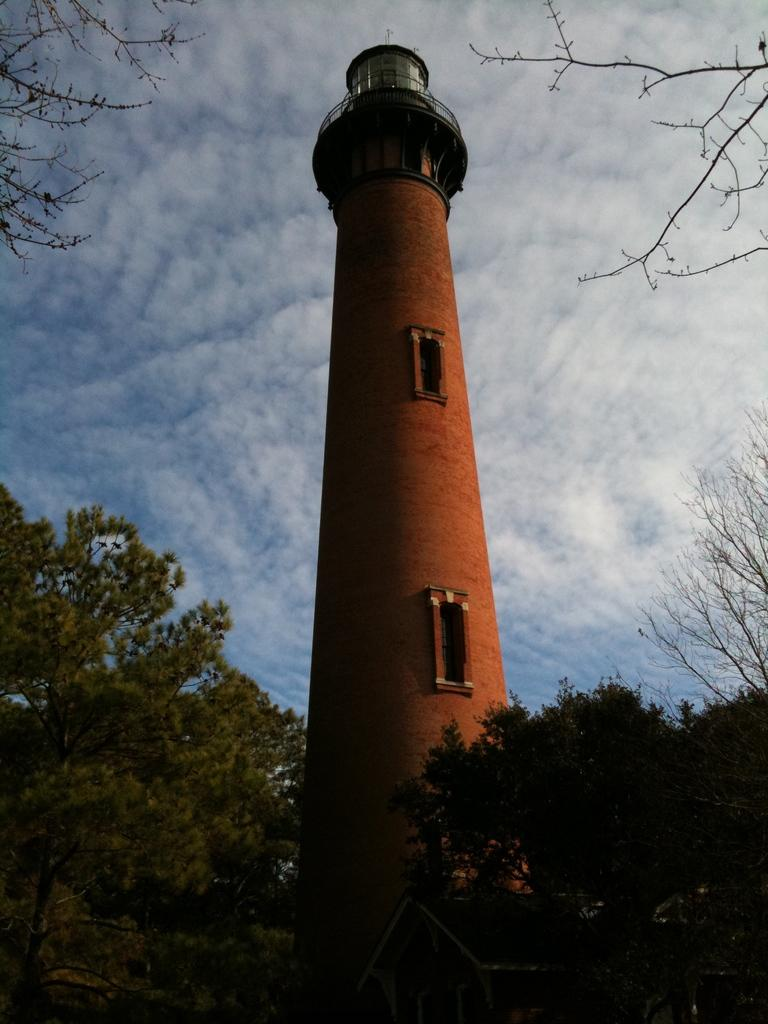What is the main structure in the middle of the image? There is a tower in the middle of the image. What type of vegetation is present in the front of the image? There are trees in the front of the image. What is visible at the top of the image? The sky is visible at the top of the image. What type of thumb can be seen holding the tower in the image? There is no thumb present in the image, and the tower is not being held by anything. 